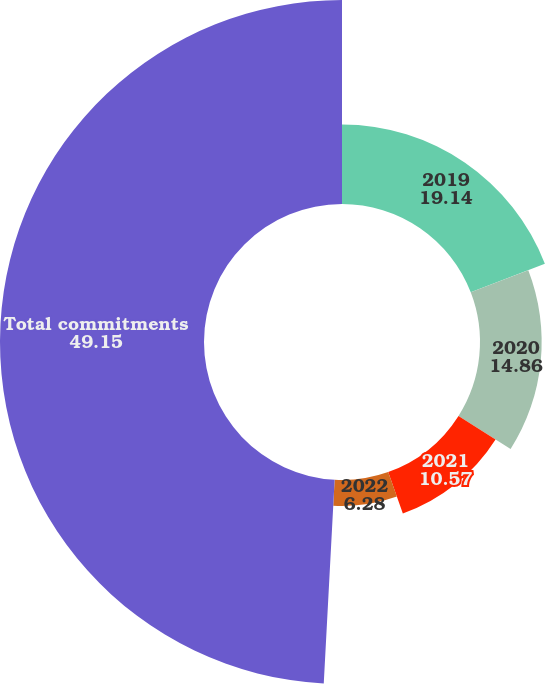<chart> <loc_0><loc_0><loc_500><loc_500><pie_chart><fcel>2019<fcel>2020<fcel>2021<fcel>2022<fcel>Total commitments<nl><fcel>19.14%<fcel>14.86%<fcel>10.57%<fcel>6.28%<fcel>49.15%<nl></chart> 